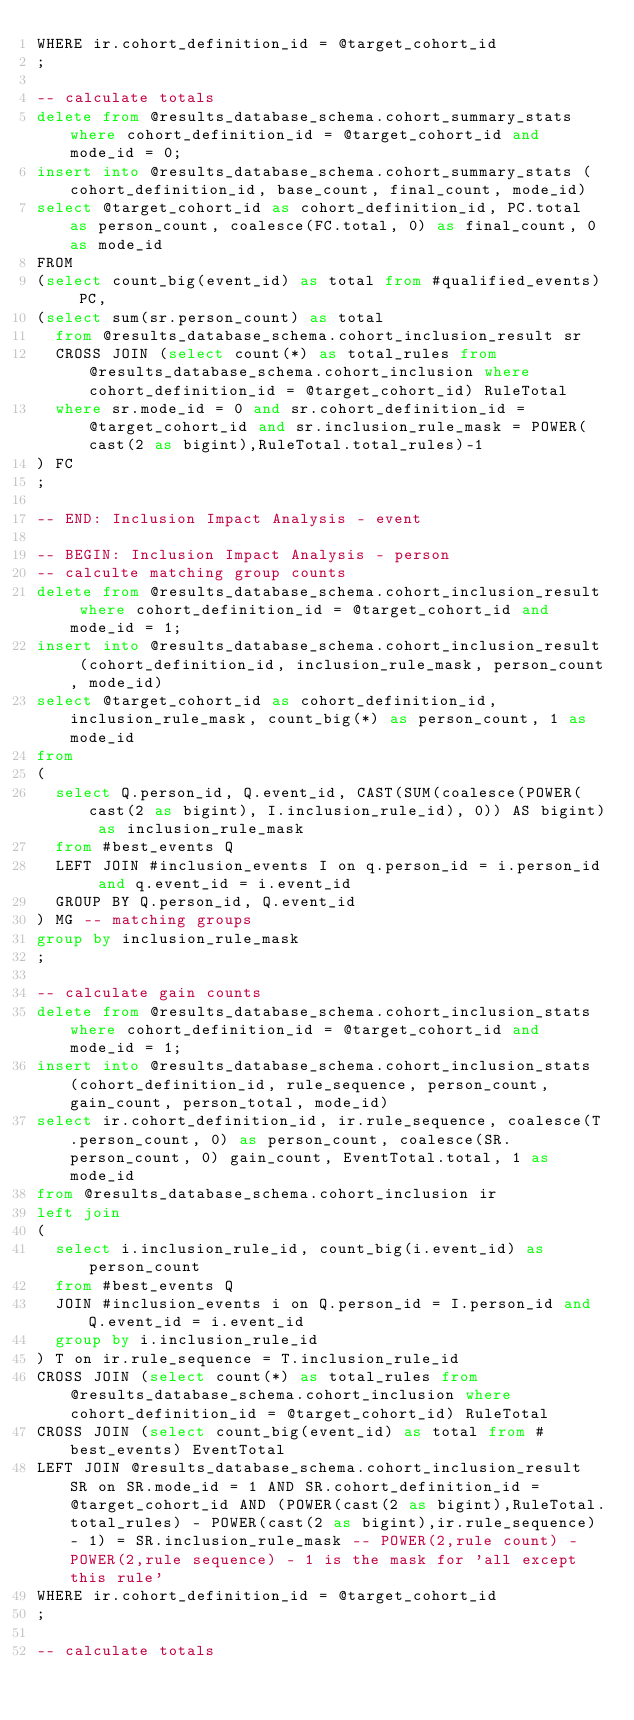<code> <loc_0><loc_0><loc_500><loc_500><_SQL_>WHERE ir.cohort_definition_id = @target_cohort_id
;

-- calculate totals
delete from @results_database_schema.cohort_summary_stats where cohort_definition_id = @target_cohort_id and mode_id = 0;
insert into @results_database_schema.cohort_summary_stats (cohort_definition_id, base_count, final_count, mode_id)
select @target_cohort_id as cohort_definition_id, PC.total as person_count, coalesce(FC.total, 0) as final_count, 0 as mode_id
FROM
(select count_big(event_id) as total from #qualified_events) PC,
(select sum(sr.person_count) as total
  from @results_database_schema.cohort_inclusion_result sr
  CROSS JOIN (select count(*) as total_rules from @results_database_schema.cohort_inclusion where cohort_definition_id = @target_cohort_id) RuleTotal
  where sr.mode_id = 0 and sr.cohort_definition_id = @target_cohort_id and sr.inclusion_rule_mask = POWER(cast(2 as bigint),RuleTotal.total_rules)-1
) FC
;

-- END: Inclusion Impact Analysis - event

-- BEGIN: Inclusion Impact Analysis - person
-- calculte matching group counts
delete from @results_database_schema.cohort_inclusion_result where cohort_definition_id = @target_cohort_id and mode_id = 1;
insert into @results_database_schema.cohort_inclusion_result (cohort_definition_id, inclusion_rule_mask, person_count, mode_id)
select @target_cohort_id as cohort_definition_id, inclusion_rule_mask, count_big(*) as person_count, 1 as mode_id
from
(
  select Q.person_id, Q.event_id, CAST(SUM(coalesce(POWER(cast(2 as bigint), I.inclusion_rule_id), 0)) AS bigint) as inclusion_rule_mask
  from #best_events Q
  LEFT JOIN #inclusion_events I on q.person_id = i.person_id and q.event_id = i.event_id
  GROUP BY Q.person_id, Q.event_id
) MG -- matching groups
group by inclusion_rule_mask
;

-- calculate gain counts 
delete from @results_database_schema.cohort_inclusion_stats where cohort_definition_id = @target_cohort_id and mode_id = 1;
insert into @results_database_schema.cohort_inclusion_stats (cohort_definition_id, rule_sequence, person_count, gain_count, person_total, mode_id)
select ir.cohort_definition_id, ir.rule_sequence, coalesce(T.person_count, 0) as person_count, coalesce(SR.person_count, 0) gain_count, EventTotal.total, 1 as mode_id
from @results_database_schema.cohort_inclusion ir
left join
(
  select i.inclusion_rule_id, count_big(i.event_id) as person_count
  from #best_events Q
  JOIN #inclusion_events i on Q.person_id = I.person_id and Q.event_id = i.event_id
  group by i.inclusion_rule_id
) T on ir.rule_sequence = T.inclusion_rule_id
CROSS JOIN (select count(*) as total_rules from @results_database_schema.cohort_inclusion where cohort_definition_id = @target_cohort_id) RuleTotal
CROSS JOIN (select count_big(event_id) as total from #best_events) EventTotal
LEFT JOIN @results_database_schema.cohort_inclusion_result SR on SR.mode_id = 1 AND SR.cohort_definition_id = @target_cohort_id AND (POWER(cast(2 as bigint),RuleTotal.total_rules) - POWER(cast(2 as bigint),ir.rule_sequence) - 1) = SR.inclusion_rule_mask -- POWER(2,rule count) - POWER(2,rule sequence) - 1 is the mask for 'all except this rule'
WHERE ir.cohort_definition_id = @target_cohort_id
;

-- calculate totals</code> 